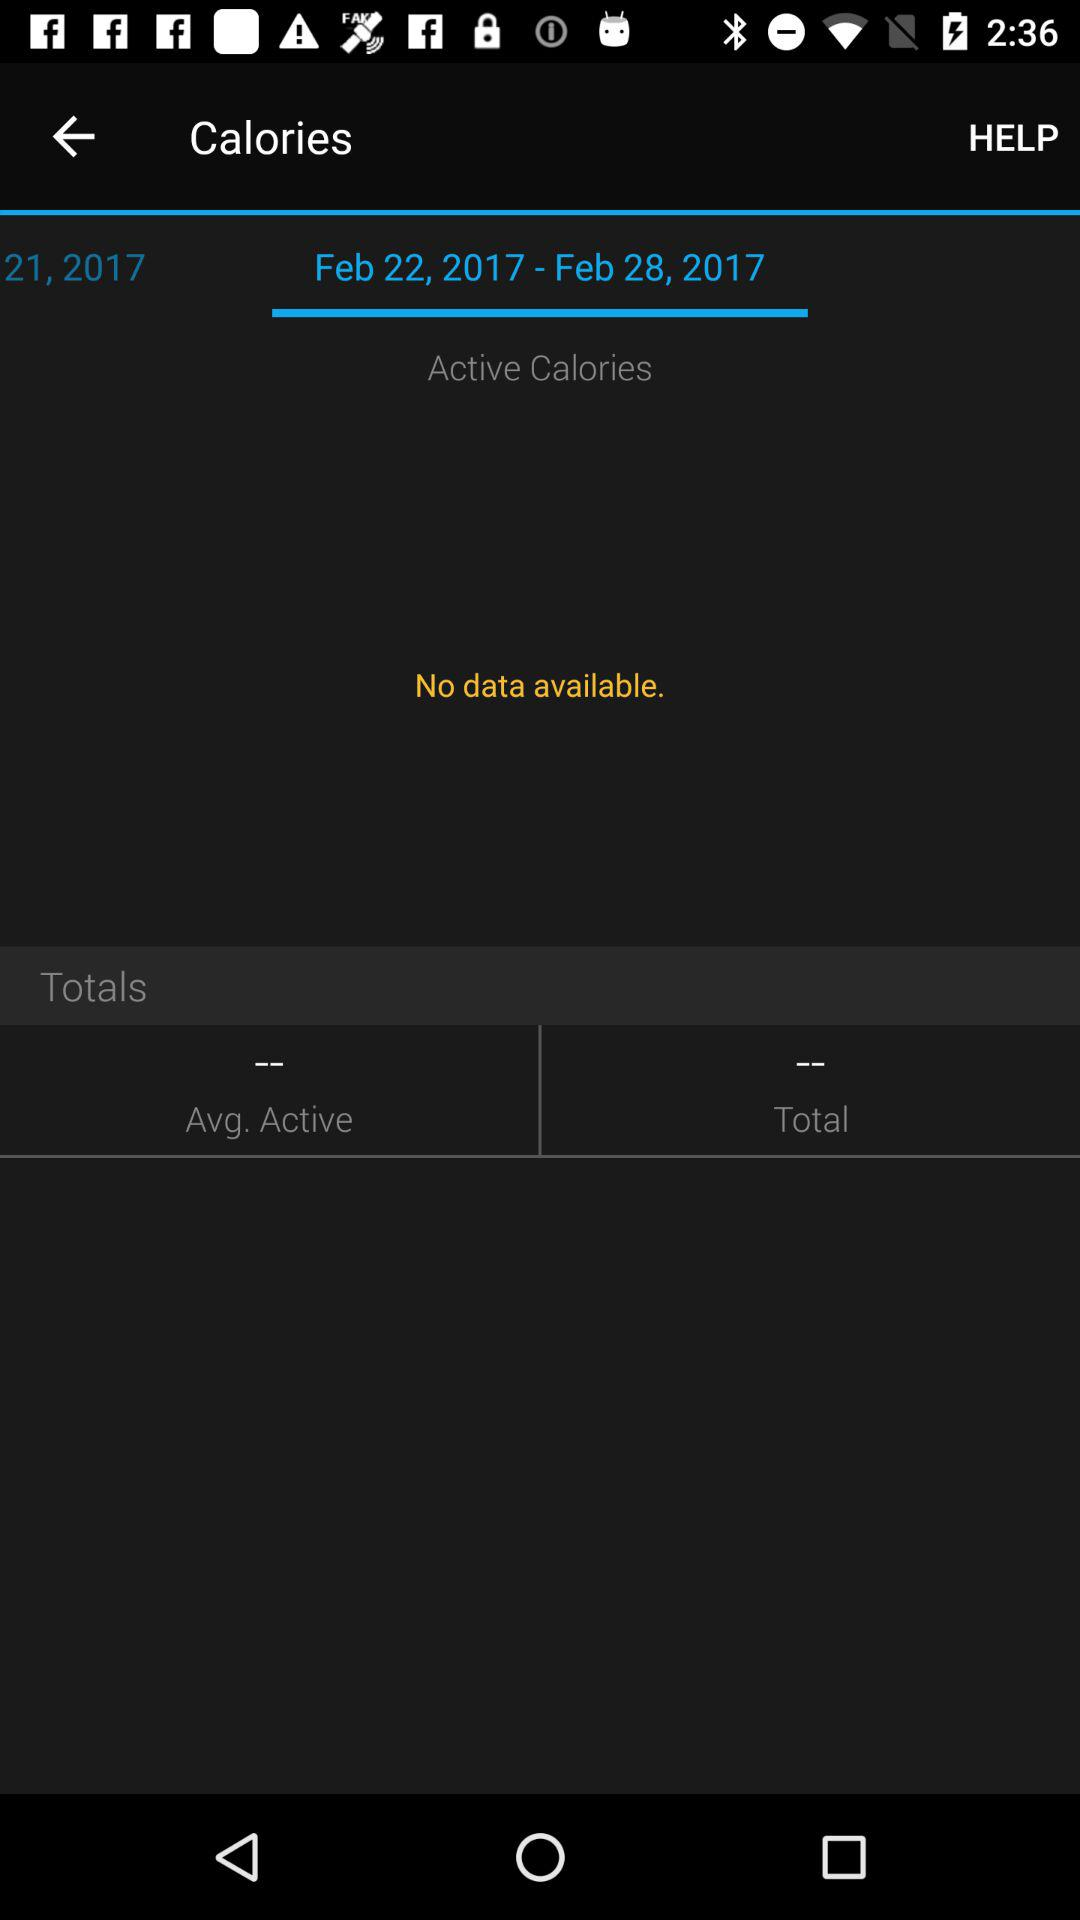Which date range is selected for data? The selected date range is from February 22, 2017 to February 28, 2017. 